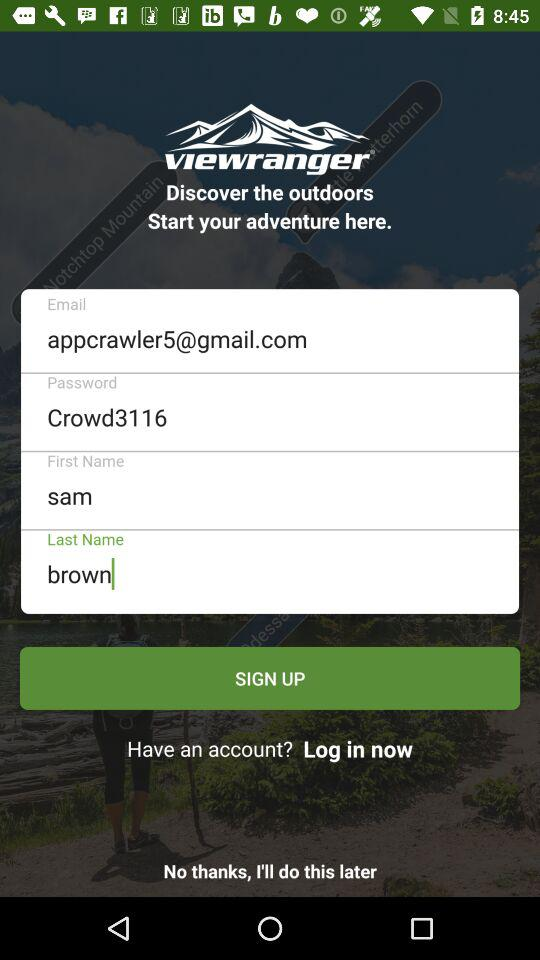What is the email address? The email address is appcrawler5@gmail.com. 